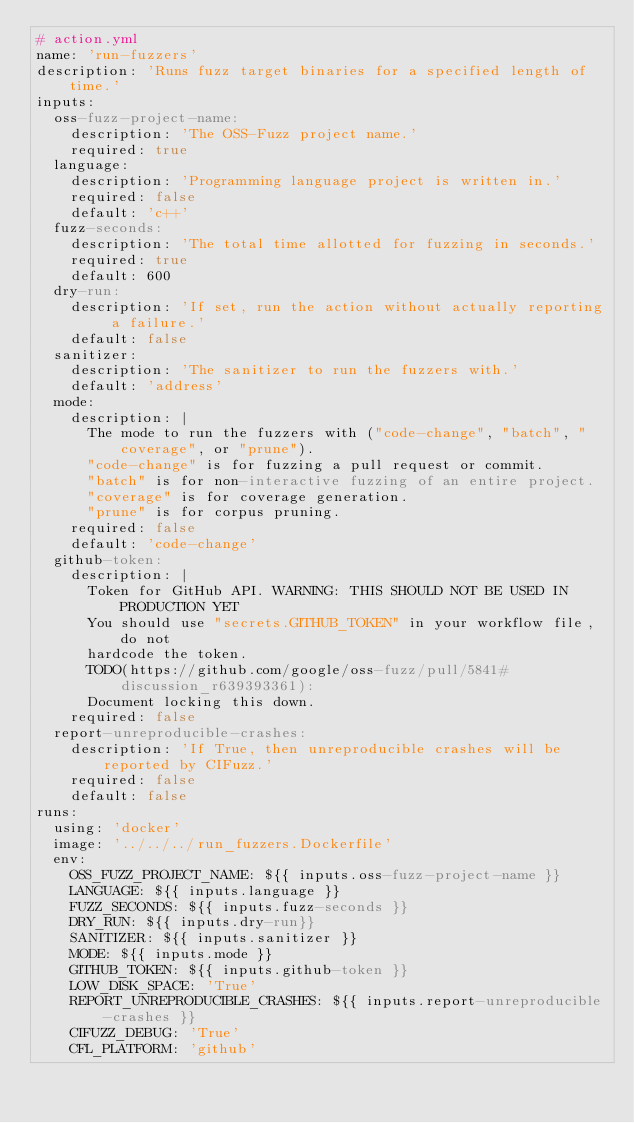Convert code to text. <code><loc_0><loc_0><loc_500><loc_500><_YAML_># action.yml
name: 'run-fuzzers'
description: 'Runs fuzz target binaries for a specified length of time.'
inputs:
  oss-fuzz-project-name:
    description: 'The OSS-Fuzz project name.'
    required: true
  language:
    description: 'Programming language project is written in.'
    required: false
    default: 'c++'
  fuzz-seconds:
    description: 'The total time allotted for fuzzing in seconds.'
    required: true
    default: 600
  dry-run:
    description: 'If set, run the action without actually reporting a failure.'
    default: false
  sanitizer:
    description: 'The sanitizer to run the fuzzers with.'
    default: 'address'
  mode:
    description: |
      The mode to run the fuzzers with ("code-change", "batch", "coverage", or "prune").
      "code-change" is for fuzzing a pull request or commit.
      "batch" is for non-interactive fuzzing of an entire project.
      "coverage" is for coverage generation.
      "prune" is for corpus pruning.
    required: false
    default: 'code-change'
  github-token:
    description: |
      Token for GitHub API. WARNING: THIS SHOULD NOT BE USED IN PRODUCTION YET
      You should use "secrets.GITHUB_TOKEN" in your workflow file, do not
      hardcode the token.
      TODO(https://github.com/google/oss-fuzz/pull/5841#discussion_r639393361):
      Document locking this down.
    required: false
  report-unreproducible-crashes:
    description: 'If True, then unreproducible crashes will be reported by CIFuzz.'
    required: false
    default: false
runs:
  using: 'docker'
  image: '../../../run_fuzzers.Dockerfile'
  env:
    OSS_FUZZ_PROJECT_NAME: ${{ inputs.oss-fuzz-project-name }}
    LANGUAGE: ${{ inputs.language }}
    FUZZ_SECONDS: ${{ inputs.fuzz-seconds }}
    DRY_RUN: ${{ inputs.dry-run}}
    SANITIZER: ${{ inputs.sanitizer }}
    MODE: ${{ inputs.mode }}
    GITHUB_TOKEN: ${{ inputs.github-token }}
    LOW_DISK_SPACE: 'True'
    REPORT_UNREPRODUCIBLE_CRASHES: ${{ inputs.report-unreproducible-crashes }}
    CIFUZZ_DEBUG: 'True'
    CFL_PLATFORM: 'github'
</code> 